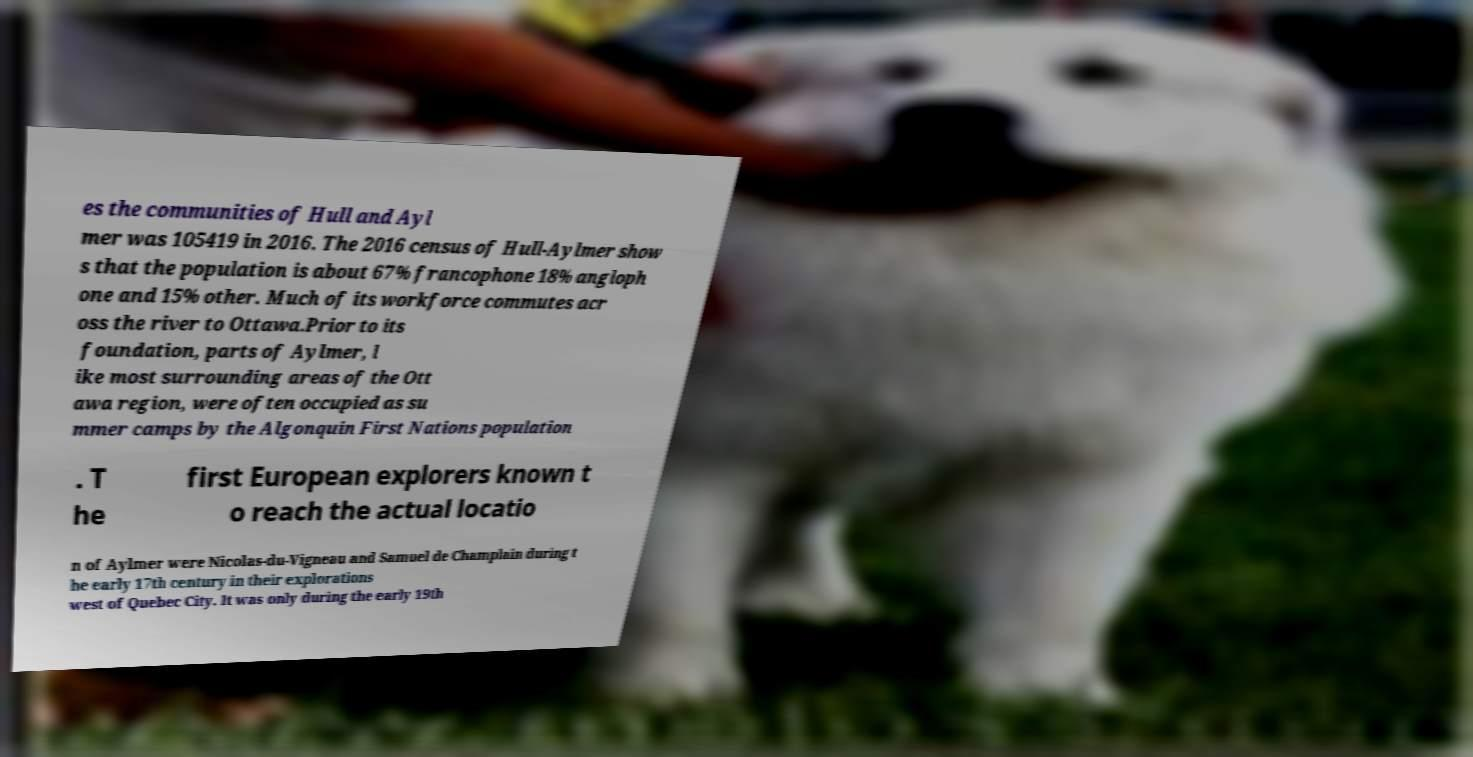Could you assist in decoding the text presented in this image and type it out clearly? es the communities of Hull and Ayl mer was 105419 in 2016. The 2016 census of Hull-Aylmer show s that the population is about 67% francophone 18% angloph one and 15% other. Much of its workforce commutes acr oss the river to Ottawa.Prior to its foundation, parts of Aylmer, l ike most surrounding areas of the Ott awa region, were often occupied as su mmer camps by the Algonquin First Nations population . T he first European explorers known t o reach the actual locatio n of Aylmer were Nicolas-du-Vigneau and Samuel de Champlain during t he early 17th century in their explorations west of Quebec City. It was only during the early 19th 